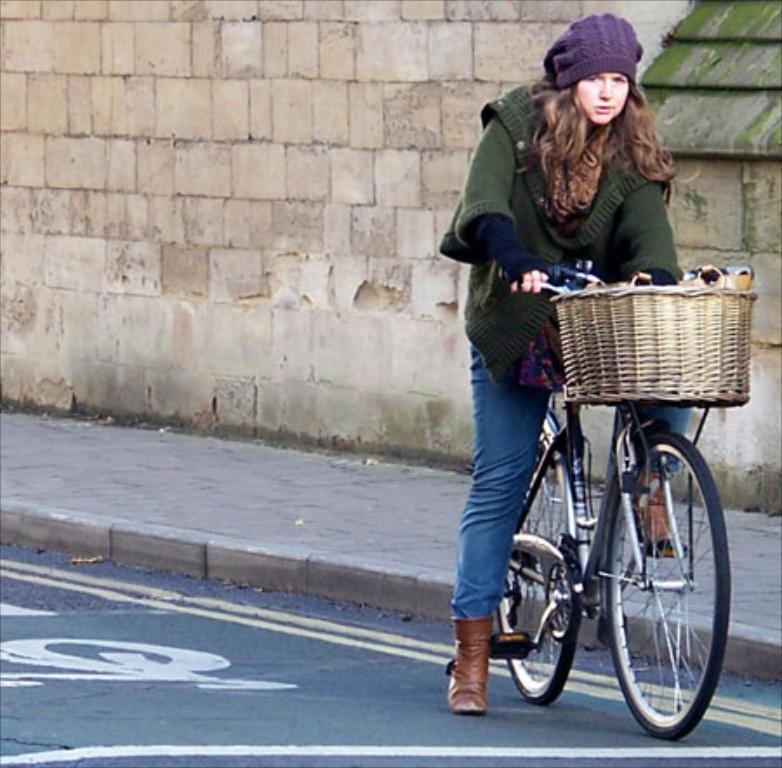How would you summarize this image in a sentence or two? A woman is sitting on a bicycle. In-front of this bicycle there is a basket. This woman wore green jacket and purple cap. 